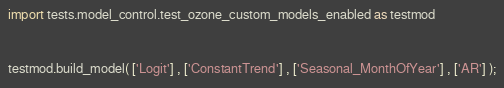<code> <loc_0><loc_0><loc_500><loc_500><_Python_>import tests.model_control.test_ozone_custom_models_enabled as testmod


testmod.build_model( ['Logit'] , ['ConstantTrend'] , ['Seasonal_MonthOfYear'] , ['AR'] );</code> 